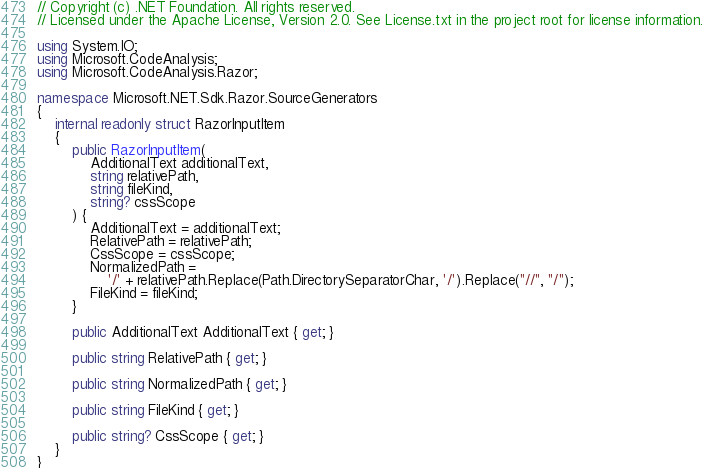<code> <loc_0><loc_0><loc_500><loc_500><_C#_>// Copyright (c) .NET Foundation. All rights reserved.
// Licensed under the Apache License, Version 2.0. See License.txt in the project root for license information.

using System.IO;
using Microsoft.CodeAnalysis;
using Microsoft.CodeAnalysis.Razor;

namespace Microsoft.NET.Sdk.Razor.SourceGenerators
{
    internal readonly struct RazorInputItem
    {
        public RazorInputItem(
            AdditionalText additionalText,
            string relativePath,
            string fileKind,
            string? cssScope
        ) {
            AdditionalText = additionalText;
            RelativePath = relativePath;
            CssScope = cssScope;
            NormalizedPath =
                '/' + relativePath.Replace(Path.DirectorySeparatorChar, '/').Replace("//", "/");
            FileKind = fileKind;
        }

        public AdditionalText AdditionalText { get; }

        public string RelativePath { get; }

        public string NormalizedPath { get; }

        public string FileKind { get; }

        public string? CssScope { get; }
    }
}
</code> 